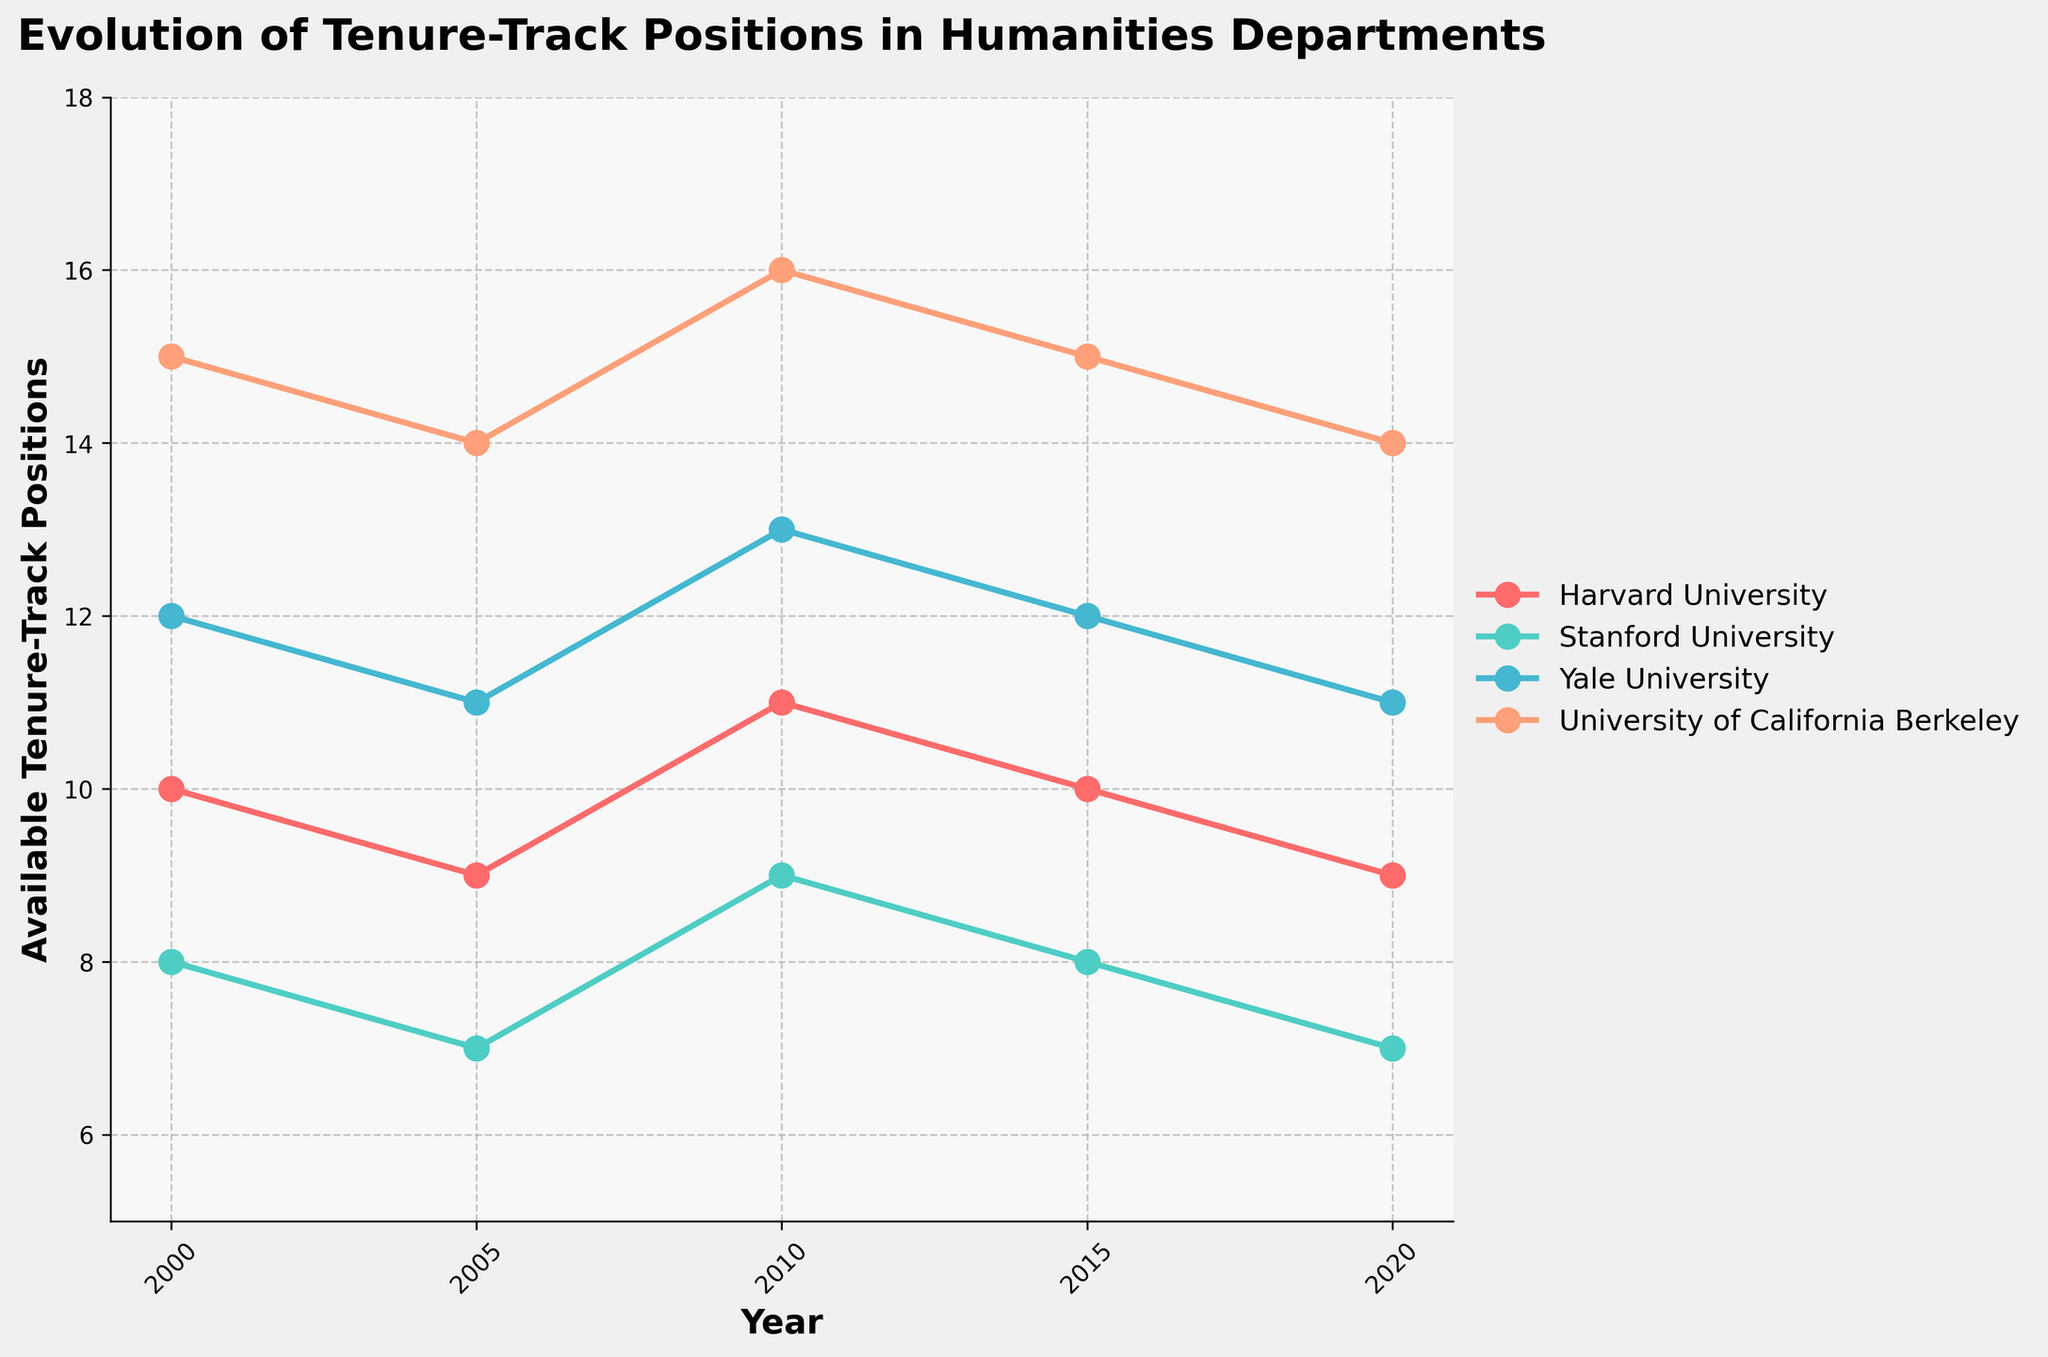What is the title of the plot? The title of the plot is written at the top and reads, "Evolution of Tenure-Track Positions in Humanities Departments."
Answer: Evolution of Tenure-Track Positions in Humanities Departments Which university had the highest number of tenure-track positions available in the year 2010? By examining the plotted lines for the year 2010 along the x-axis, the University of California Berkeley has the highest data point with 16 available tenure-track positions.
Answer: University of California Berkeley How many universities are compared in the plot? The plot contains four distinct lines, each representing data from different universities. Therefore, there are four universities compared in the plot.
Answer: Four Between which years did Stanford University maintain a constant number of available positions? By tracking Stanford University's data points (colored line) across the years, the number of positions remains constant between 2015 and 2020 at 7 positions.
Answer: 2015 and 2020 Which university shows a decrease in the number of tenure-track positions from 2000 to 2005? By examining the data points for each university, Harvard University shows a drop from 10 to 9 positions between 2000 and 2005.
Answer: Harvard University What is the total available tenure-track positions in 2005 across all universities? Sum the positions for Harvard University (9), Stanford University (7), Yale University (11), and University of California Berkeley (14) in 2005, which is 9 + 7 + 11 + 14 = 41 positions.
Answer: 41 Which university demonstrates a cyclical pattern in the number of available tenure-track positions? Yale University shows a cyclical pattern with positions rising in 2010 and then falling back in 2015 and 2020.
Answer: Yale University What is the average number of tenure-track positions available at Stanford University during the period 2000 to 2020? First, sum the positions for Stanford University from 2000, 2005, 2010, 2015, and 2020: 8 + 7 + 9 + 8 + 7 = 39. Then, divide by the number of data points (5): 39/5 = 7.8 positions.
Answer: 7.8 Which university had the least variance in available tenure-track positions over the period? By visually comparing the fluctuations in the plot, Stanford University shows the least variance, maintaining a narrow range between 7 and 9 positions.
Answer: Stanford University 